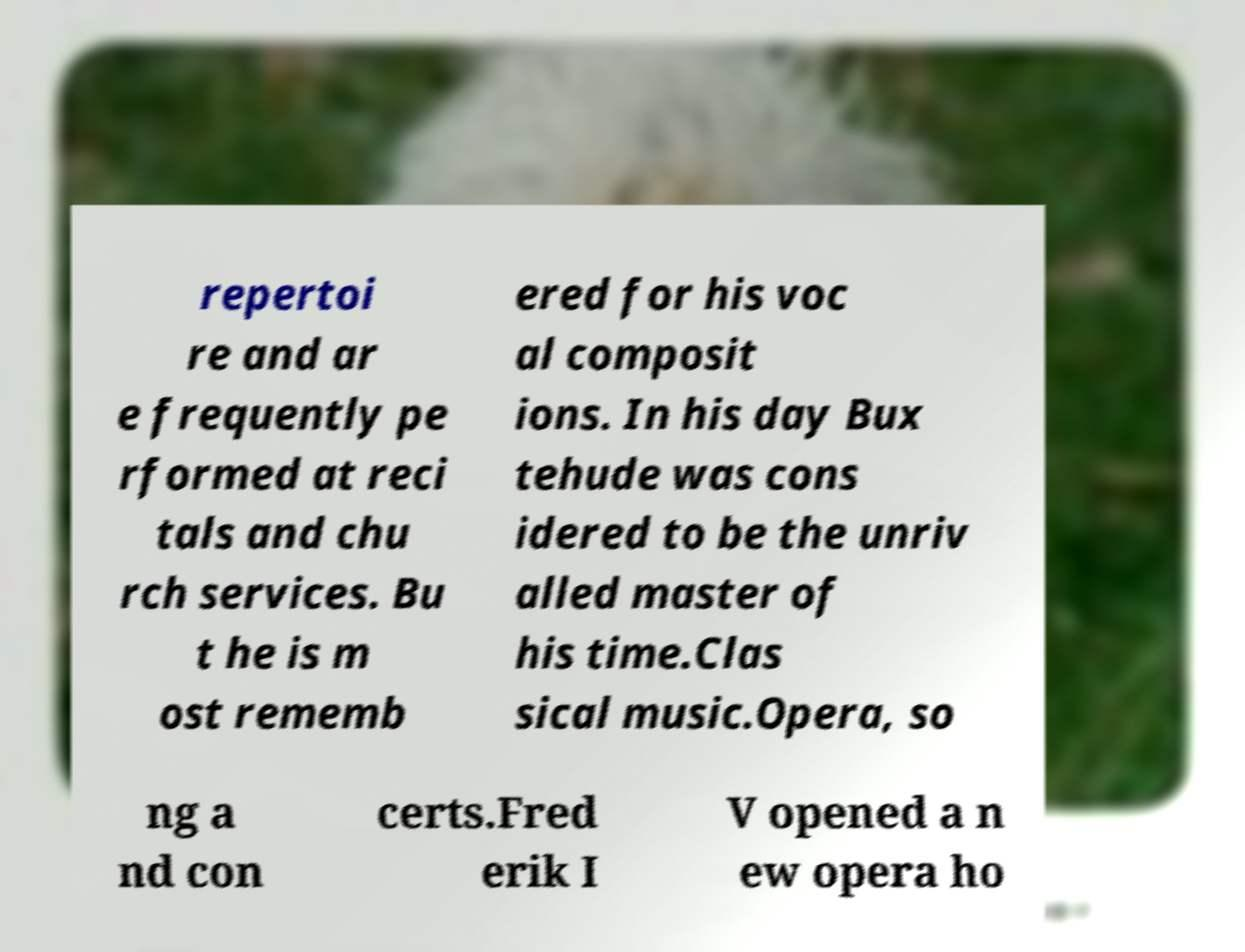I need the written content from this picture converted into text. Can you do that? repertoi re and ar e frequently pe rformed at reci tals and chu rch services. Bu t he is m ost rememb ered for his voc al composit ions. In his day Bux tehude was cons idered to be the unriv alled master of his time.Clas sical music.Opera, so ng a nd con certs.Fred erik I V opened a n ew opera ho 